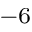<formula> <loc_0><loc_0><loc_500><loc_500>^ { - 6 }</formula> 